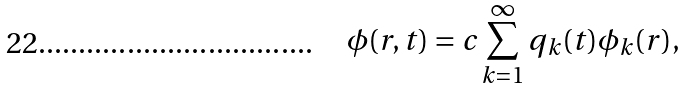<formula> <loc_0><loc_0><loc_500><loc_500>\phi ( { r } , t ) = c \sum _ { k = 1 } ^ { \infty } q _ { k } ( t ) \phi _ { k } ( { r } ) ,</formula> 